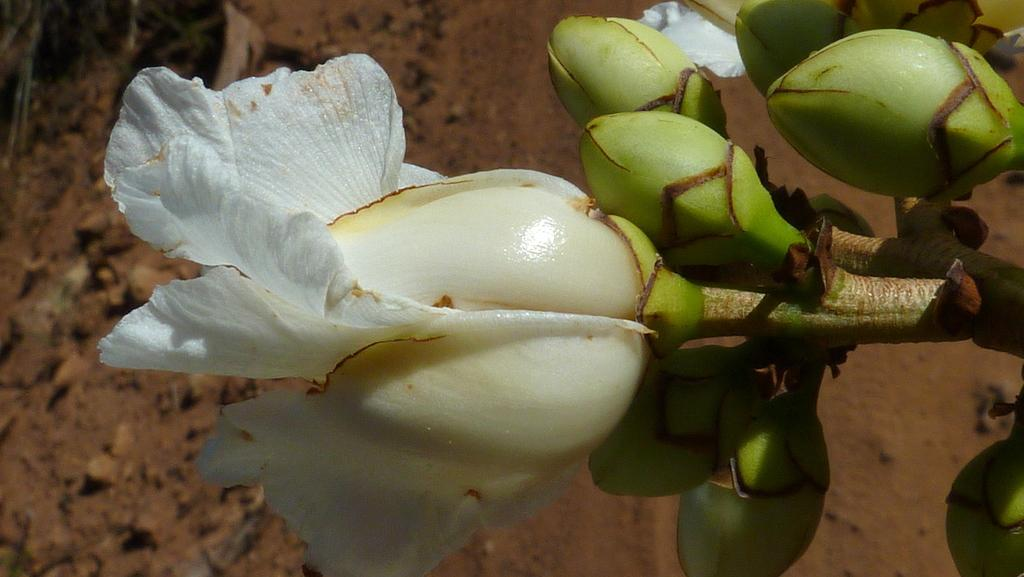What is the main subject of the image? There is a flower in the center of the image. Can you describe the background of the image? There is ground visible in the background of the image. What type of whip can be seen cracking in the image? There is no whip present in the image; it features a flower and ground. How many matches are visible in the image? There are no matches present in the image. 